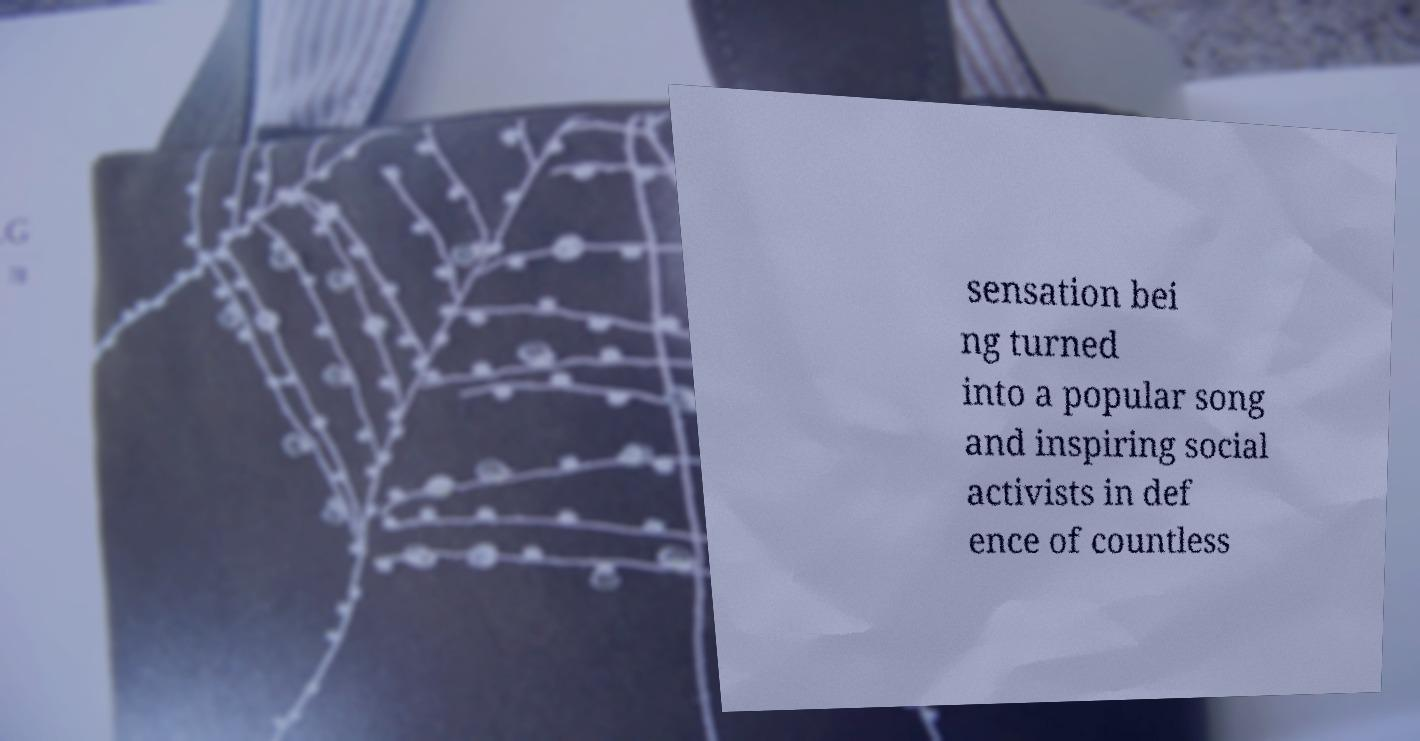Please identify and transcribe the text found in this image. sensation bei ng turned into a popular song and inspiring social activists in def ence of countless 